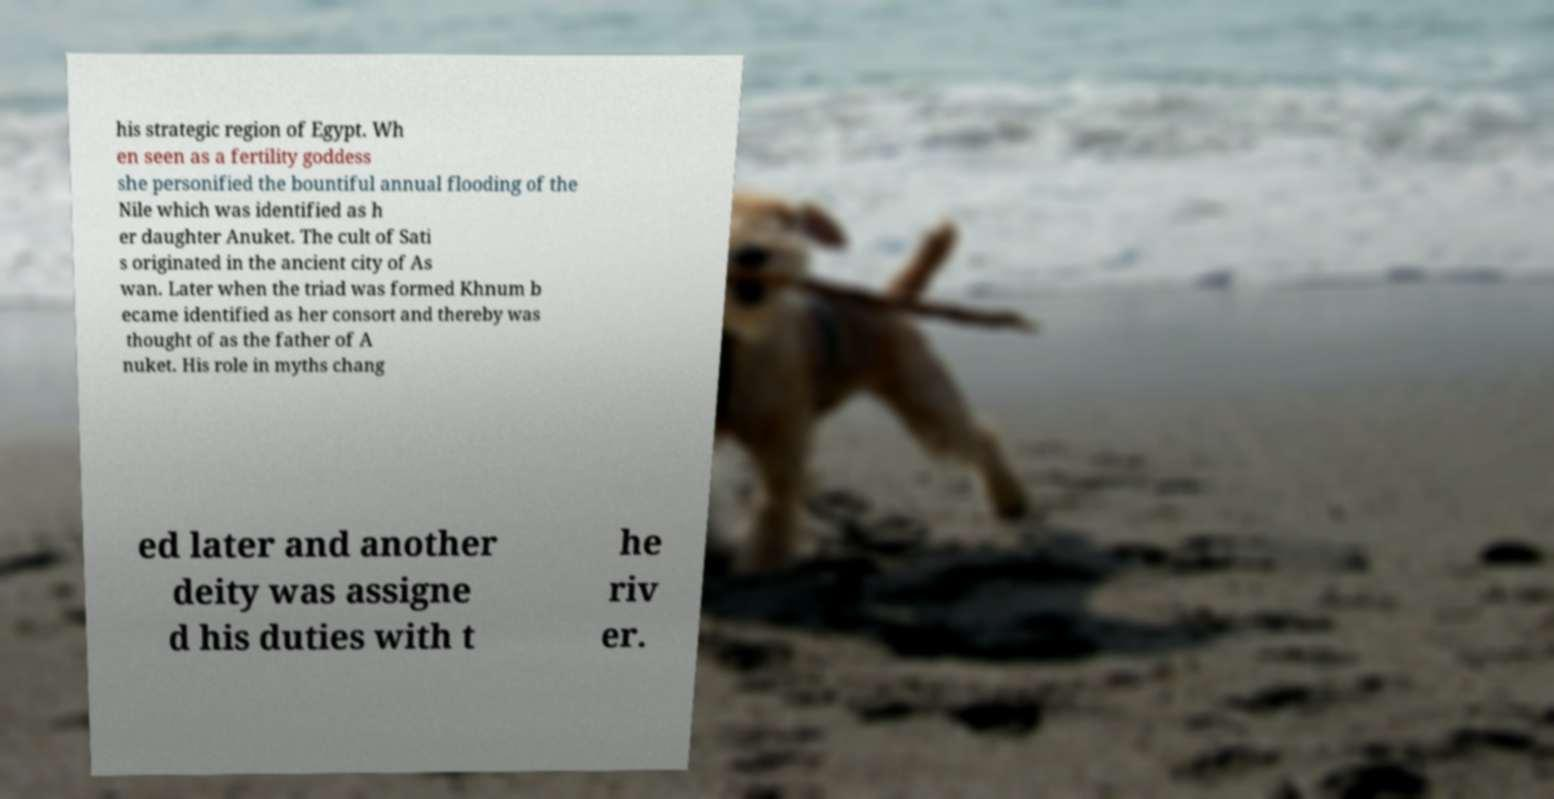Please identify and transcribe the text found in this image. his strategic region of Egypt. Wh en seen as a fertility goddess she personified the bountiful annual flooding of the Nile which was identified as h er daughter Anuket. The cult of Sati s originated in the ancient city of As wan. Later when the triad was formed Khnum b ecame identified as her consort and thereby was thought of as the father of A nuket. His role in myths chang ed later and another deity was assigne d his duties with t he riv er. 